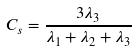Convert formula to latex. <formula><loc_0><loc_0><loc_500><loc_500>C _ { s } = \frac { 3 \lambda _ { 3 } } { \lambda _ { 1 } + \lambda _ { 2 } + \lambda _ { 3 } }</formula> 